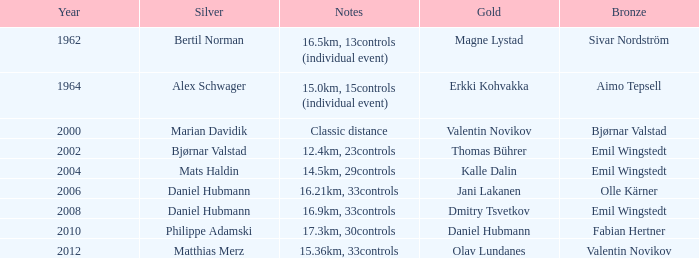WHAT IS THE YEAR WITH A BRONZE OF AIMO TEPSELL? 1964.0. 